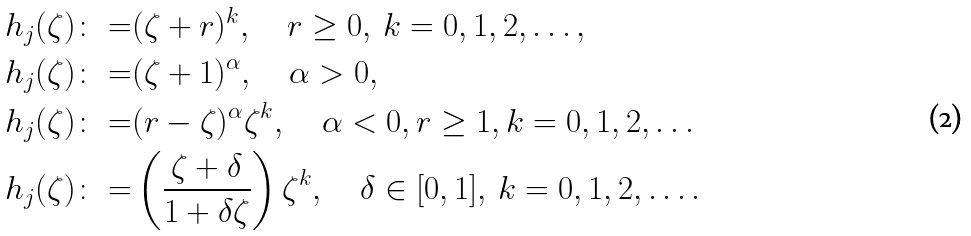Convert formula to latex. <formula><loc_0><loc_0><loc_500><loc_500>h _ { j } ( \zeta ) \colon = & ( \zeta + r ) ^ { k } , \quad r \geq 0 , \, k = 0 , 1 , 2 , \dots , \\ h _ { j } ( \zeta ) \colon = & ( \zeta + 1 ) ^ { \alpha } , \quad \alpha > 0 , \\ h _ { j } ( \zeta ) \colon = & ( r - \zeta ) ^ { \alpha } \zeta ^ { k } , \quad \alpha < 0 , r \geq 1 , k = 0 , 1 , 2 , \dots \\ h _ { j } ( \zeta ) \colon = & \left ( \frac { \zeta + \delta } { 1 + \delta \zeta } \right ) \zeta ^ { k } , \quad \delta \in [ 0 , 1 ] , \, k = 0 , 1 , 2 , \dots .</formula> 